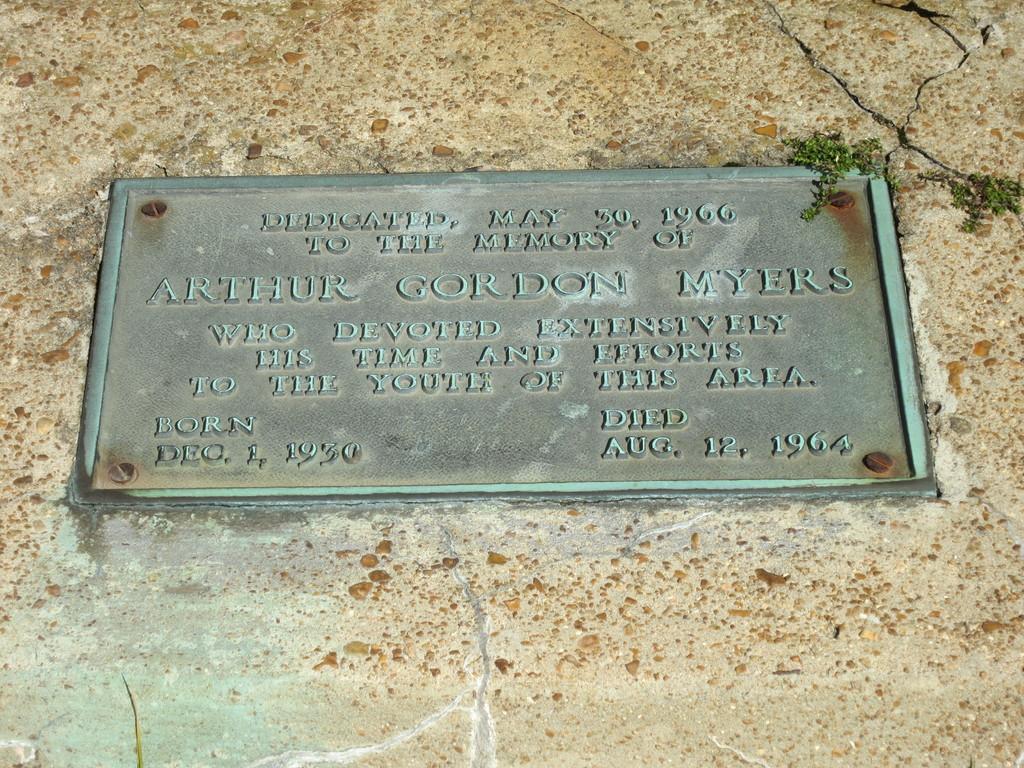Could you give a brief overview of what you see in this image? In this picture we can observe a board fixed to the wall. We can observe some words carved on this board. There are small plants on the right side. We can observe a crack here. 